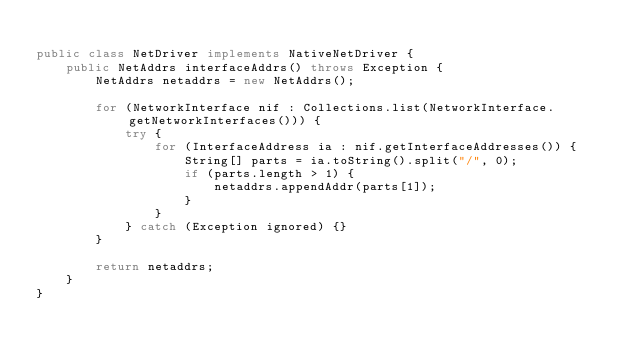Convert code to text. <code><loc_0><loc_0><loc_500><loc_500><_Java_>
public class NetDriver implements NativeNetDriver {
    public NetAddrs interfaceAddrs() throws Exception {
        NetAddrs netaddrs = new NetAddrs();

        for (NetworkInterface nif : Collections.list(NetworkInterface.getNetworkInterfaces())) {
            try {
                for (InterfaceAddress ia : nif.getInterfaceAddresses()) {
                    String[] parts = ia.toString().split("/", 0);
                    if (parts.length > 1) {
                        netaddrs.appendAddr(parts[1]);
                    }
                }
            } catch (Exception ignored) {}
        }

        return netaddrs;
    }
}
</code> 